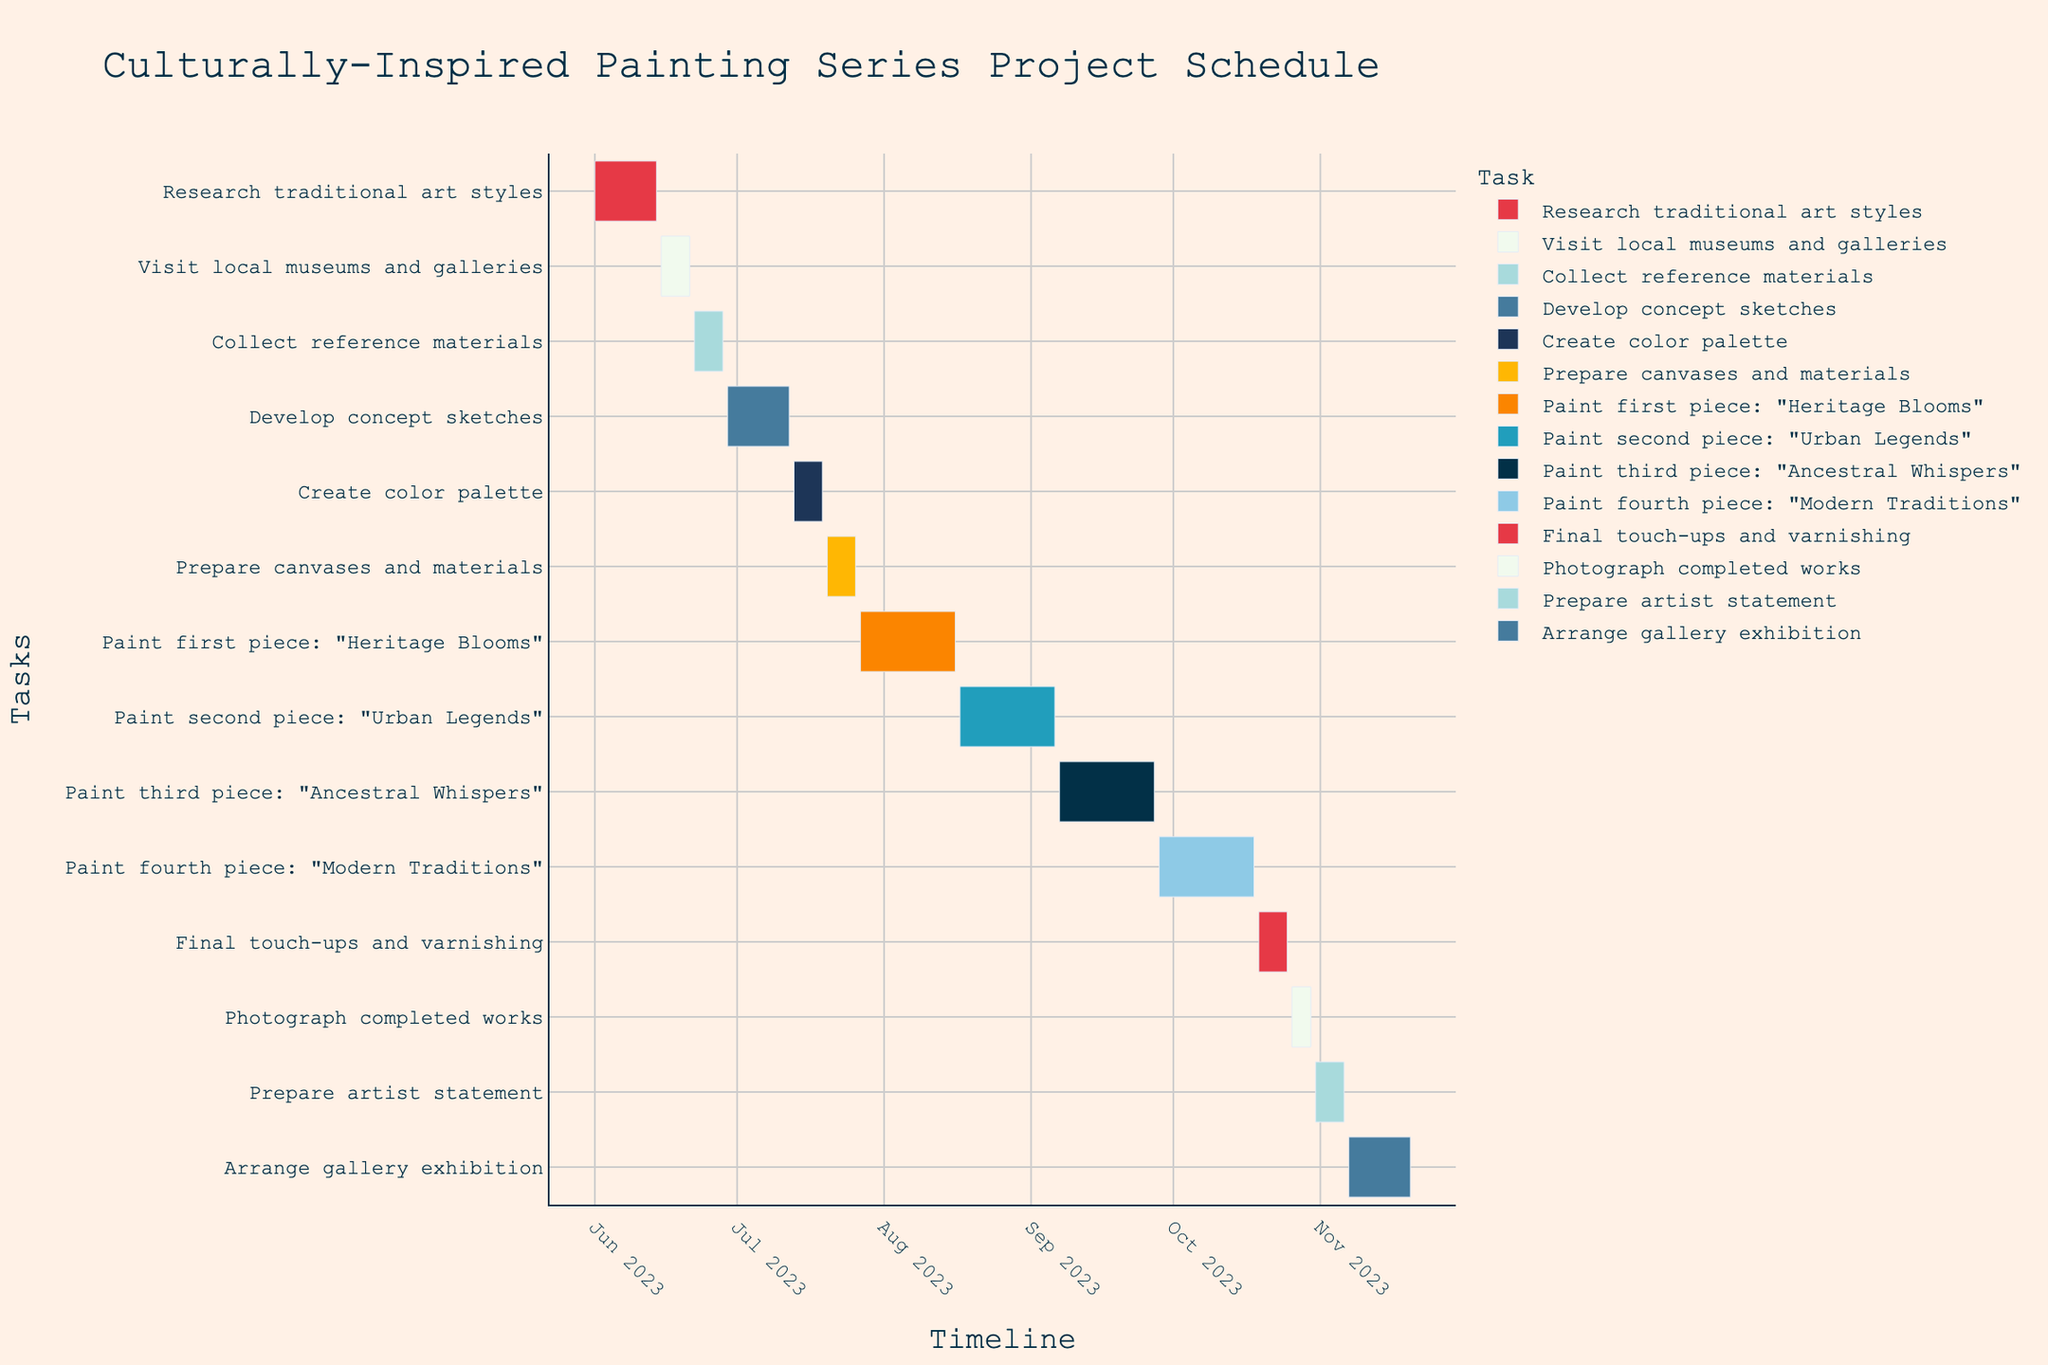What is the title of the Gantt Chart? The title of the Gantt Chart is displayed prominently at the top. Simply read the title text to note it down.
Answer: Culturally-Inspired Painting Series Project Schedule During which dates is the task "Develop concept sketches" scheduled to occur? Locate the "Develop concept sketches" task on the vertical axis (y-axis). Trace horizontally to find the start and end dates on the timeline (x-axis).
Answer: June 29, 2023, to July 12, 2023 Which task lasts the longest, and what is its duration? Compare durations of all tasks by observing the lengths of the bars representing each task on the chart. The longest bar is the task with the longest duration. The duration can be deduced from the start and end dates or calculated if not directly marked.
Answer: Paint fourth piece: "Modern Traditions", 21 days How many days are allocated for "Collect reference materials"? Trace the "Collect reference materials" task bar from its start date to its end date and calculate the difference.
Answer: 7 days For the task "Paint first piece: 'Heritage Blooms'", does it overlap with "Prepare canvases and materials"? Analyze the timeline to see if the duration of "Paint first piece: 'Heritage Blooms'" shares any common dates with "Prepare canvases and materials".
Answer: Yes How do the durations of "Final touch-ups and varnishing" and "Photograph completed works" compare? Locate both tasks and measure their durations by counting the days between their start and end dates, then compare these durations.
Answer: "Final touch-ups and varnishing" is longer than "Photograph completed works" What is the combined duration of the research-related tasks (Research traditional art styles, Visit local museums and galleries, Collect reference materials)? Sum the durations of each individual research-related task by calculating the difference between start and end dates and then adding these durations together.
Answer: 21 days Which milestone marks the transition from preparation to painting? Identify tasks related to preparation and locate the transition point where the preparation tasks end and painting tasks start.
Answer: Prepare canvases and materials Are there any gaps or breaks between the preparation and painting phases? Analyze the start and end dates of tasks to determine if there are any non-overlapping days, indicating gaps between the tasks in the preparation and painting phases.
Answer: No Which two tasks occur concurrently with "Arrange gallery exhibition"? Observe the timeline for tasks that share overlapping dates with "Arrange gallery exhibition".
Answer: None 